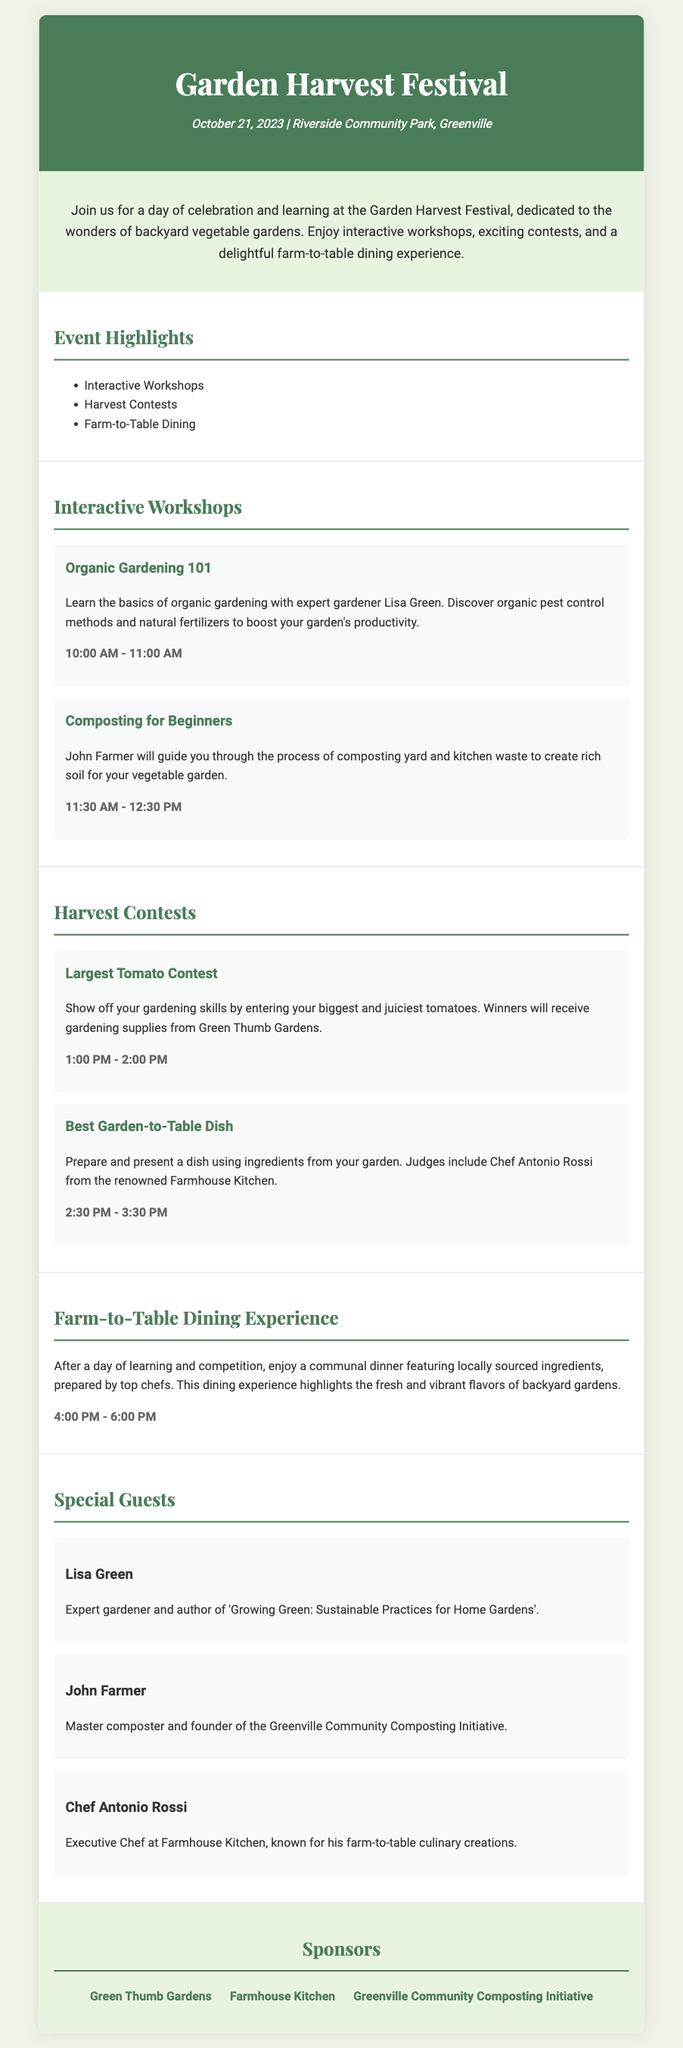What is the date of the Garden Harvest Festival? The date of the event is mentioned in the document as October 21, 2023.
Answer: October 21, 2023 Where is the festival being held? The location of the event is specified in the document as Riverside Community Park, Greenville.
Answer: Riverside Community Park, Greenville Who is leading the "Organic Gardening 101" workshop? The document states that Lisa Green is the expert leading this workshop.
Answer: Lisa Green What contest involves presenting a dish made from garden ingredients? The contest for this theme is described as "Best Garden-to-Table Dish."
Answer: Best Garden-to-Table Dish At what time does the "Largest Tomato Contest" start? The schedule shows that the contest starts at 1:00 PM.
Answer: 1:00 PM What type of dining experience is offered at the festival? The document specifies that there will be a Farm-to-Table Dining Experience featuring locally sourced ingredients.
Answer: Farm-to-Table Dining Experience Which guest is known for sustainable gardening practices? The guest known for this is Lisa Green, who authored a book on sustainable practices.
Answer: Lisa Green How long is the "Composting for Beginners" workshop? The duration of the workshop is provided in the document as 1 hour.
Answer: 1 hour 